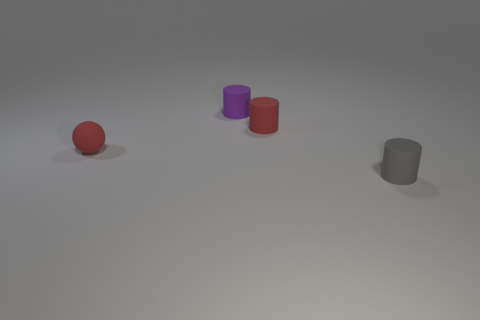Are there the same number of tiny rubber things to the right of the tiny purple cylinder and tiny gray things behind the tiny red sphere?
Your answer should be very brief. No. There is a gray thing that is the same shape as the purple matte thing; what material is it?
Your answer should be very brief. Rubber. Is there a small gray matte thing that is in front of the small cylinder to the right of the red rubber thing to the right of the purple matte cylinder?
Keep it short and to the point. No. There is a rubber thing in front of the small red ball; does it have the same shape as the tiny red object that is in front of the small red rubber cylinder?
Your answer should be compact. No. Is the number of red objects that are to the left of the red matte cylinder greater than the number of tiny cylinders?
Offer a terse response. No. How many objects are big blue metallic cubes or small red objects?
Ensure brevity in your answer.  2. What is the color of the matte sphere?
Your response must be concise. Red. What number of other things are the same color as the matte ball?
Your response must be concise. 1. There is a sphere; are there any cylinders on the right side of it?
Keep it short and to the point. Yes. What color is the object that is left of the purple matte cylinder that is left of the small red thing that is behind the tiny red rubber ball?
Offer a terse response. Red. 